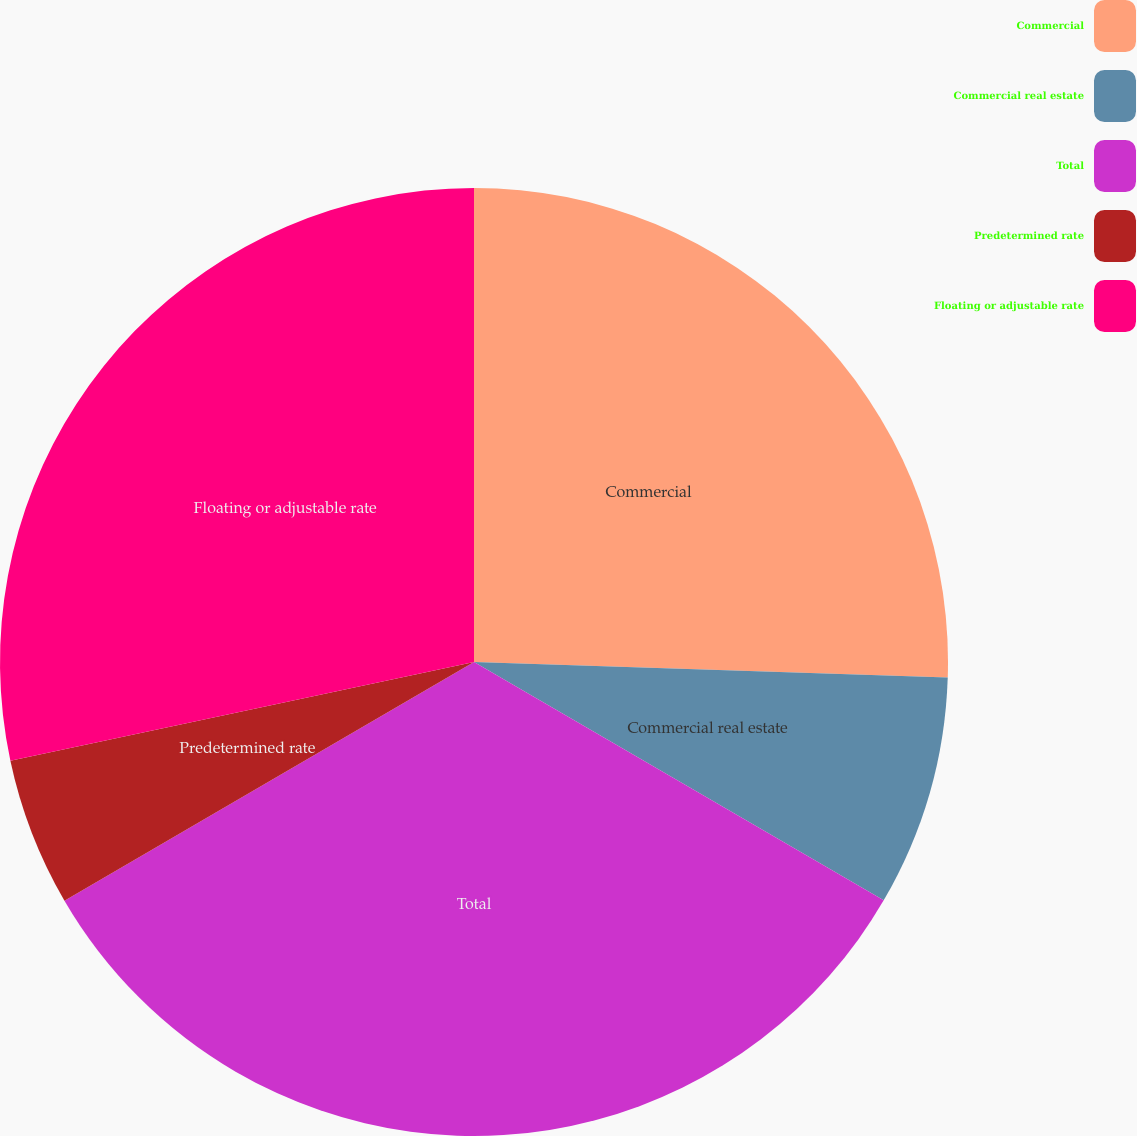Convert chart to OTSL. <chart><loc_0><loc_0><loc_500><loc_500><pie_chart><fcel>Commercial<fcel>Commercial real estate<fcel>Total<fcel>Predetermined rate<fcel>Floating or adjustable rate<nl><fcel>25.52%<fcel>7.87%<fcel>33.22%<fcel>5.06%<fcel>28.34%<nl></chart> 